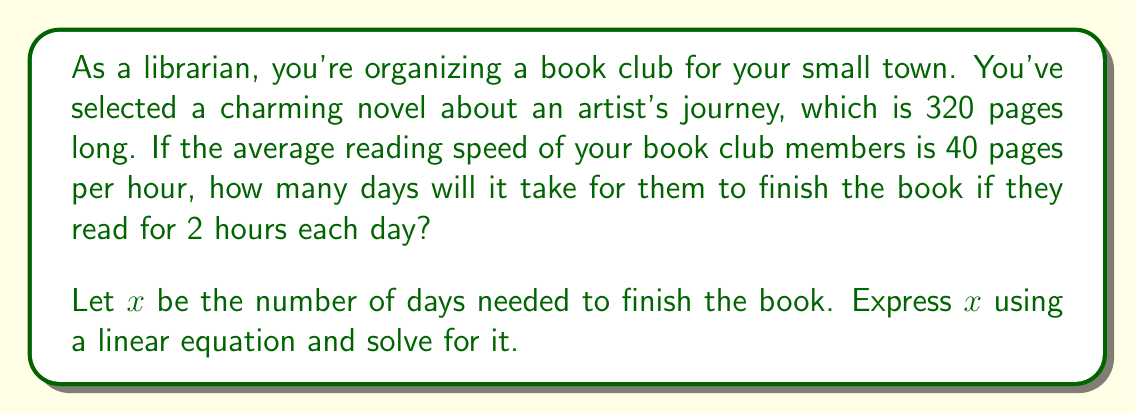Can you answer this question? Let's approach this step-by-step:

1) First, let's identify the known variables:
   - Total pages in the book: 320
   - Reading speed: 40 pages per hour
   - Reading time per day: 2 hours

2) Now, let's set up our equation:
   - Pages read per day = Reading speed × Reading time per day
   - Pages read per day = 40 × 2 = 80 pages

3) We can now form a linear equation:
   $80x = 320$
   Where $x$ is the number of days needed to finish the book.

4) To solve for $x$, we divide both sides by 80:
   $$\frac{80x}{80} = \frac{320}{80}$$
   $$x = 4$$

5) Therefore, it will take 4 days to finish the book.

This problem demonstrates a real-world application of linear equations, where we use the relationship between time, speed, and distance (or in this case, pages) to solve for an unknown variable.
Answer: $x = 4$ days 